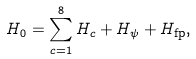Convert formula to latex. <formula><loc_0><loc_0><loc_500><loc_500>H _ { 0 } = \sum _ { c = 1 } ^ { 8 } H _ { c } + H _ { \psi } + H _ { \text {fp} } ,</formula> 